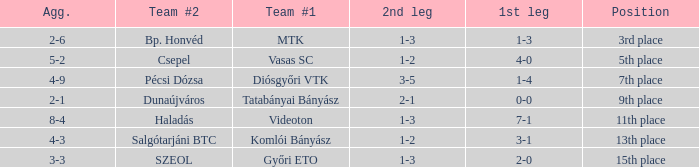What is the 1st leg with a 4-3 agg.? 3-1. 